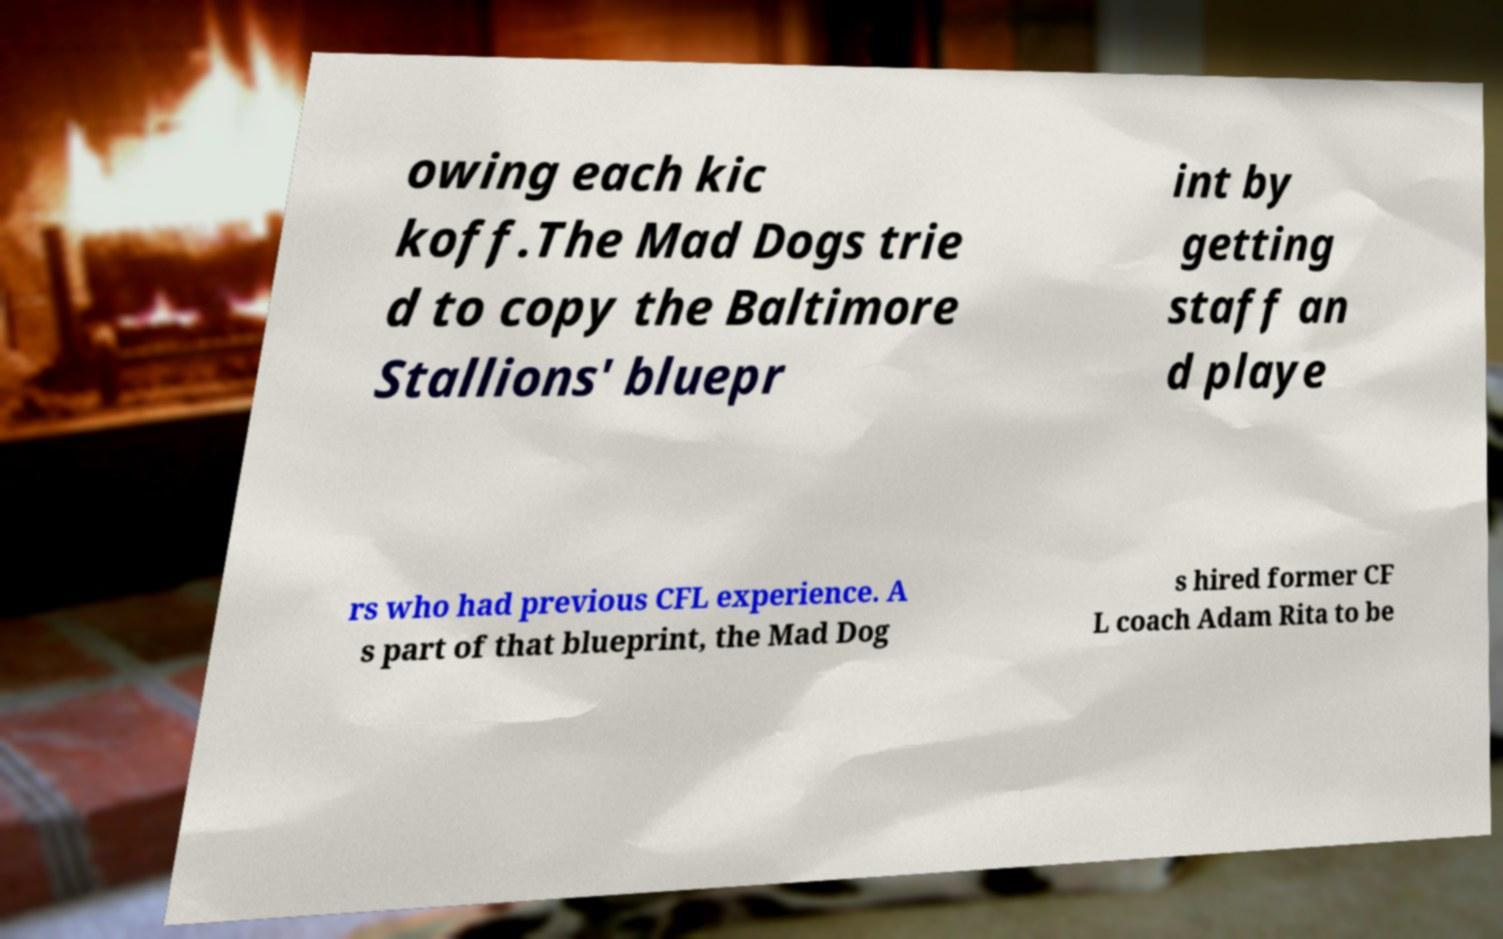Please identify and transcribe the text found in this image. owing each kic koff.The Mad Dogs trie d to copy the Baltimore Stallions' bluepr int by getting staff an d playe rs who had previous CFL experience. A s part of that blueprint, the Mad Dog s hired former CF L coach Adam Rita to be 